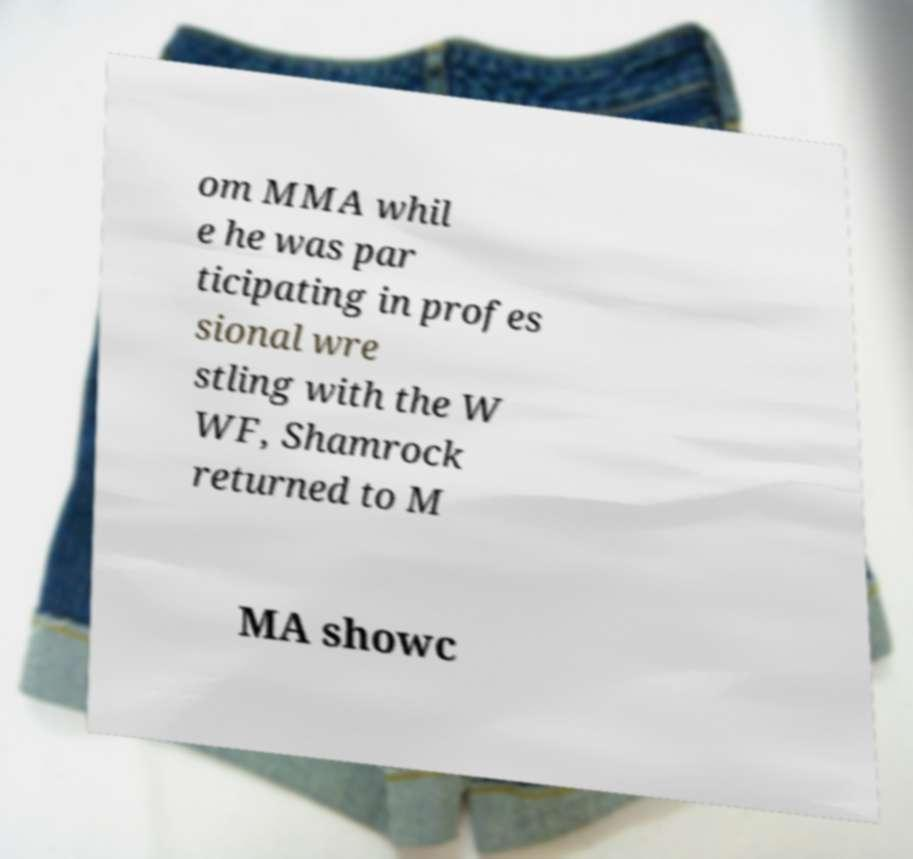Can you read and provide the text displayed in the image?This photo seems to have some interesting text. Can you extract and type it out for me? om MMA whil e he was par ticipating in profes sional wre stling with the W WF, Shamrock returned to M MA showc 